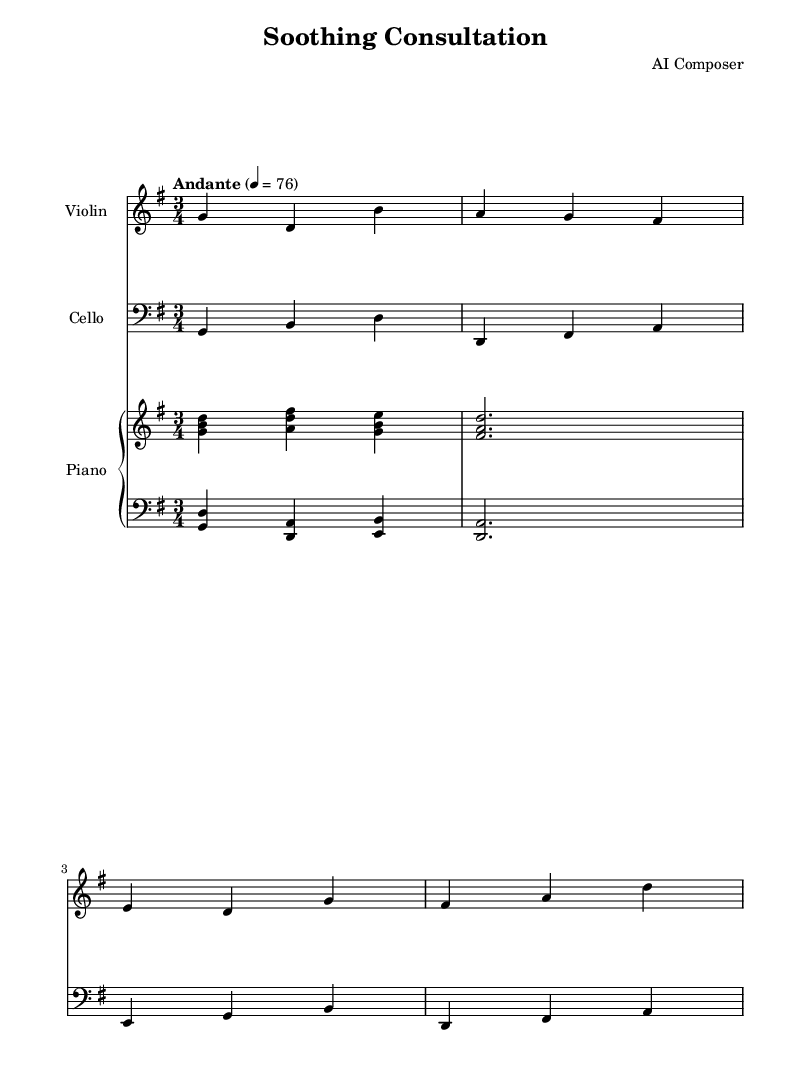What is the key signature of this music? The key signature is G major, which has one sharp (F#).
Answer: G major What is the time signature of the piece? The time signature is 3/4, indicating three beats in each measure.
Answer: 3/4 What is the tempo marking of this piece? The tempo marking is Andante, suggesting a moderate pace.
Answer: Andante How many instruments are present in this score? There are three instruments: violin, cello, and piano.
Answer: Three How many measures are in the main theme of the music? The main theme has four measures, which can be counted from the start to the end of the section.
Answer: Four What is the dynamic level indicated for the piano part? The dynamic level is not specified in the score, implying it is to be played softly in the background.
Answer: Softly Which instruments are in the treble and bass clefs? The treble clef is used for the violin and right hand of the piano, while the bass clef is used for the cello and left hand of the piano.
Answer: Violin and cello 